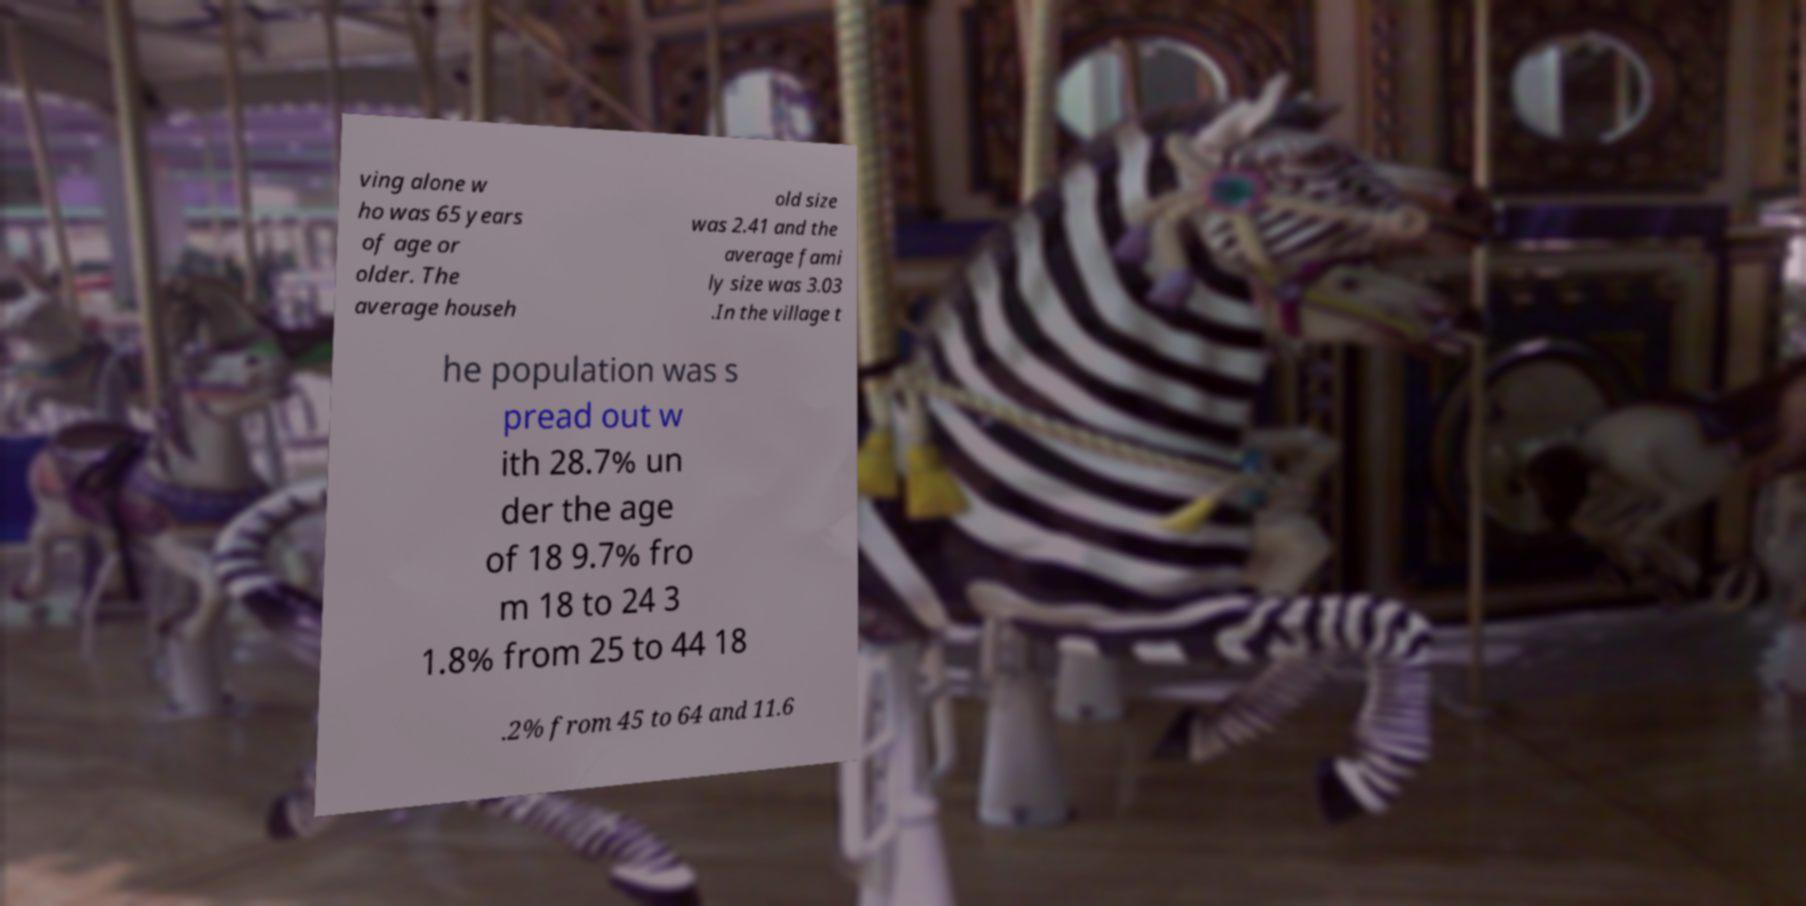Can you accurately transcribe the text from the provided image for me? ving alone w ho was 65 years of age or older. The average househ old size was 2.41 and the average fami ly size was 3.03 .In the village t he population was s pread out w ith 28.7% un der the age of 18 9.7% fro m 18 to 24 3 1.8% from 25 to 44 18 .2% from 45 to 64 and 11.6 